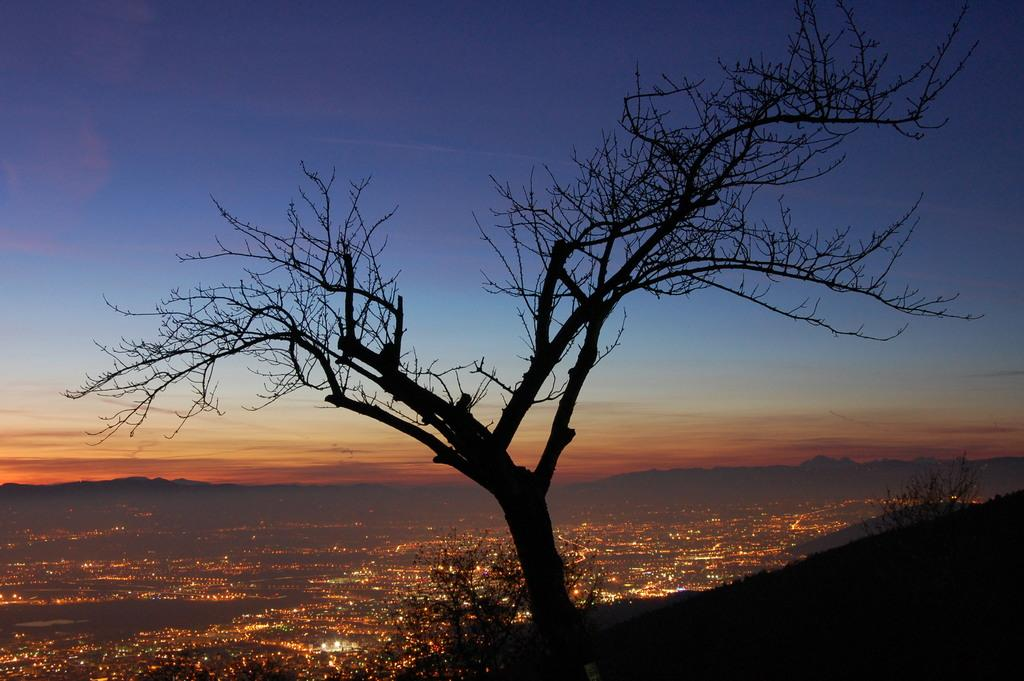What type of tree is visible in the image? There is a dried tree in the image. What is the perspective of the image? The image shows a top angle view of a city. What type of love can be seen on the mouth of the finger in the image? There is no love, mouth, or finger present in the image. 